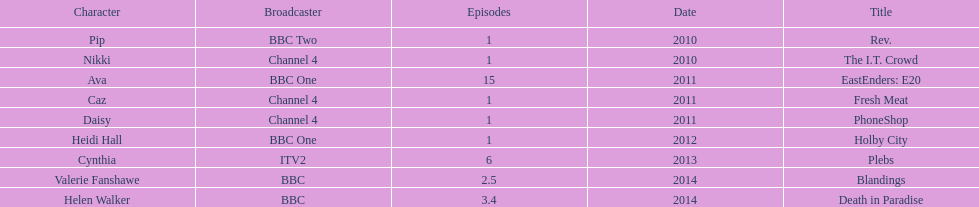How many titles have at least 5 episodes? 2. 